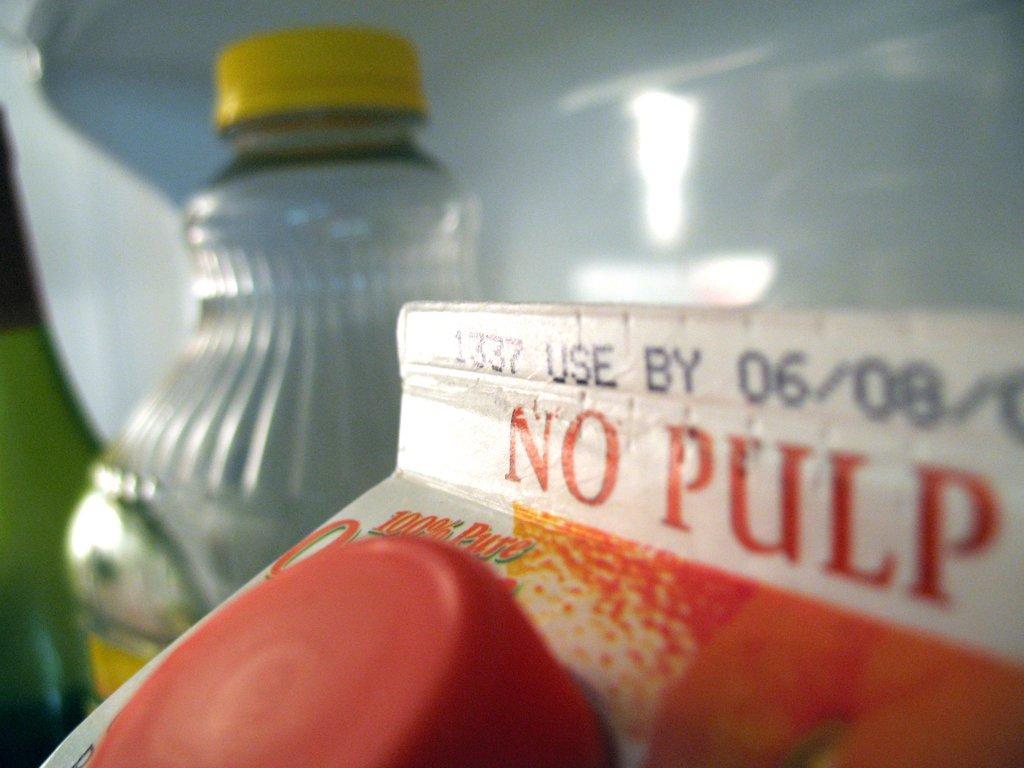Could you give a brief overview of what you see in this image? This is a juice packer with a cap and something written over there. In the background there is a bottle with yellow cap. 